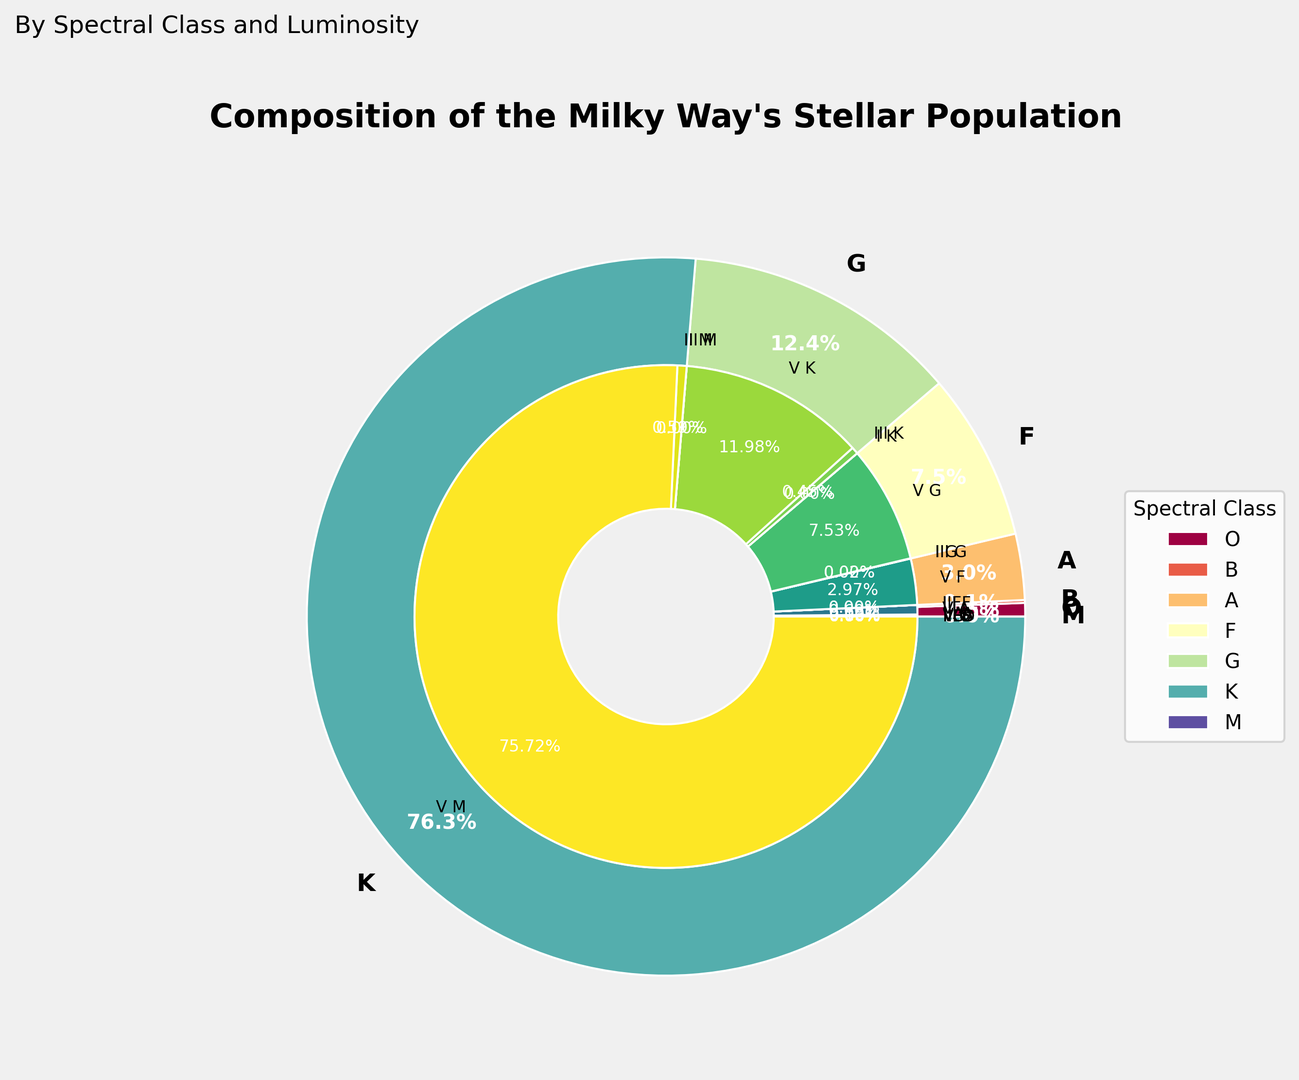Which spectral class has the highest percentage of the Milky Way's stellar population? Looking at the outer pie chart, the slice for the "M" spectral class is the largest, indicating that it has the highest percentage.
Answer: M Which luminosity class within spectral class G has the highest percentage? By observing the inner sections within the "G" spectral class slice, the largest portion is the "V G" classification.
Answer: V What is the combined percentage of luminosity class V stars across all spectral classes? Summing the respective percentages for luminosity class V stars across all spectral classes: O V (0.00015) + B V (0.13) + A V (0.61) + F V (3.0) + G V (7.6) + K V (12.1) + M V (76.45). The calculation is 0.00015 + 0.13 + 0.61 + 3.0 + 7.6 + 12.1 + 76.45 = 99.89.
Answer: 99.89% Which has a higher percentage: Luminosity class III stars in spectral class K or luminosity class I stars in spectral class G? Comparing the slices: K III has 0.45% and G I has 0.0004%. The value for K III is greater.
Answer: K III What is the difference in percentage between luminosity class V stars in spectral classes A and F? Subtracting the percentage of A V stars from F V stars: 3.0% - 0.61% = 2.39%.
Answer: 2.39% Considering spectral classes K and F, which one has a higher total percentage of stars in luminosity classes I and III combined? Calculating the sum for spectral class K: K I (0.0005) + K III (0.45) = 0.4505. For spectral class F: F I (0.0003) + F III (0.0012) = 0.0015. Comparing the two sums, 0.4505 is greater than 0.0015.
Answer: K What percentage of the Milky Way's stellar population is composed of spectral class O stars? Referring to the outer pie chart slice associated with spectral class O: the label indicates the sum of O class stars' percentages as 0.00001 + 0.00004 + 0.00015 = 0.0002%.
Answer: 0.0002% Which visual colors dominate the inner pie chart for the spectral classes M and K? Spectral class M's inner sections are mostly dark green as indicated by the "viridis" colormap, while spectral class K's inner pie slices are mid-range shades of green.
Answer: dark green (M), mid-range green (K) 